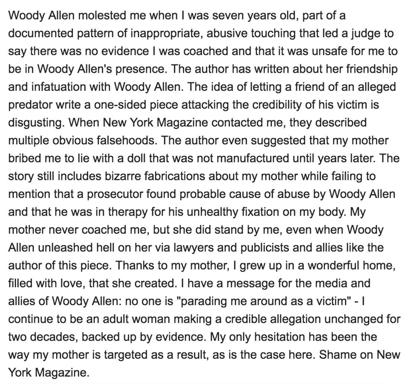What is the main subject of the text in the image? The primary subject of the text is the author's serious accusation against Woody Allen, claiming he molested her at the age of seven. The text also vigorously critiques a biased article in New York Magazine, which the author feels perpetuates falsehoods and omits crucial evidence of abuse that was recognized by legal authorities. 